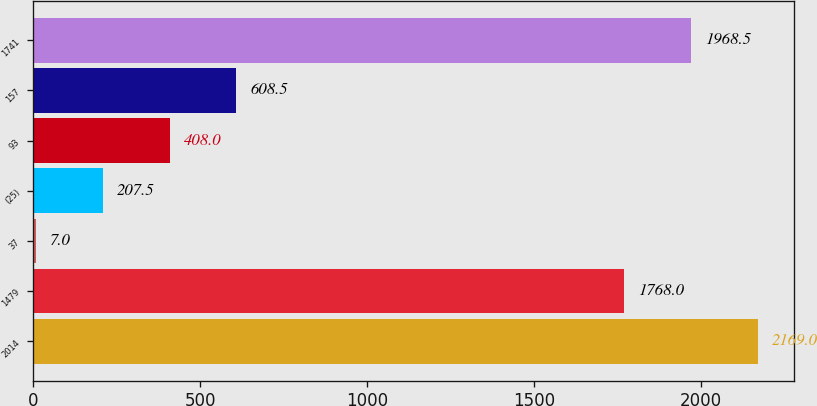<chart> <loc_0><loc_0><loc_500><loc_500><bar_chart><fcel>2014<fcel>1479<fcel>37<fcel>(25)<fcel>93<fcel>157<fcel>1741<nl><fcel>2169<fcel>1768<fcel>7<fcel>207.5<fcel>408<fcel>608.5<fcel>1968.5<nl></chart> 